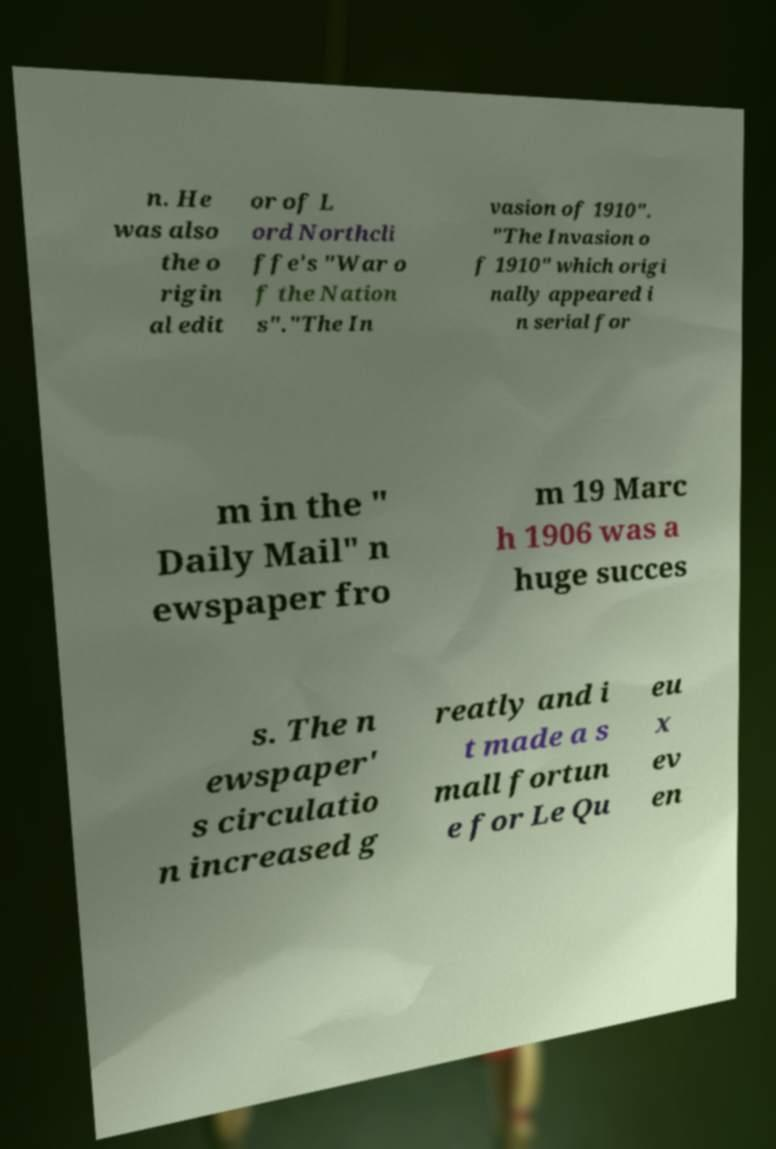There's text embedded in this image that I need extracted. Can you transcribe it verbatim? n. He was also the o rigin al edit or of L ord Northcli ffe's "War o f the Nation s"."The In vasion of 1910". "The Invasion o f 1910" which origi nally appeared i n serial for m in the " Daily Mail" n ewspaper fro m 19 Marc h 1906 was a huge succes s. The n ewspaper' s circulatio n increased g reatly and i t made a s mall fortun e for Le Qu eu x ev en 